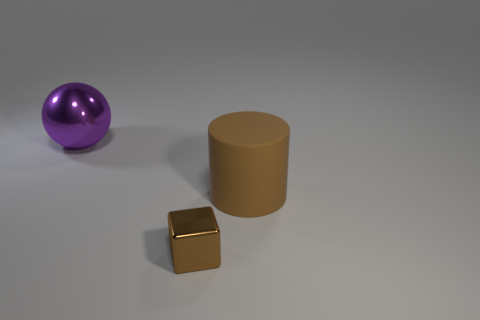Subtract 1 cylinders. How many cylinders are left? 0 Add 2 tiny purple rubber balls. How many objects exist? 5 Subtract all cylinders. How many objects are left? 2 Subtract all red matte balls. Subtract all brown cubes. How many objects are left? 2 Add 1 purple metal spheres. How many purple metal spheres are left? 2 Add 1 brown cubes. How many brown cubes exist? 2 Subtract 0 cyan blocks. How many objects are left? 3 Subtract all cyan balls. Subtract all purple cylinders. How many balls are left? 1 Subtract all red cubes. How many cyan cylinders are left? 0 